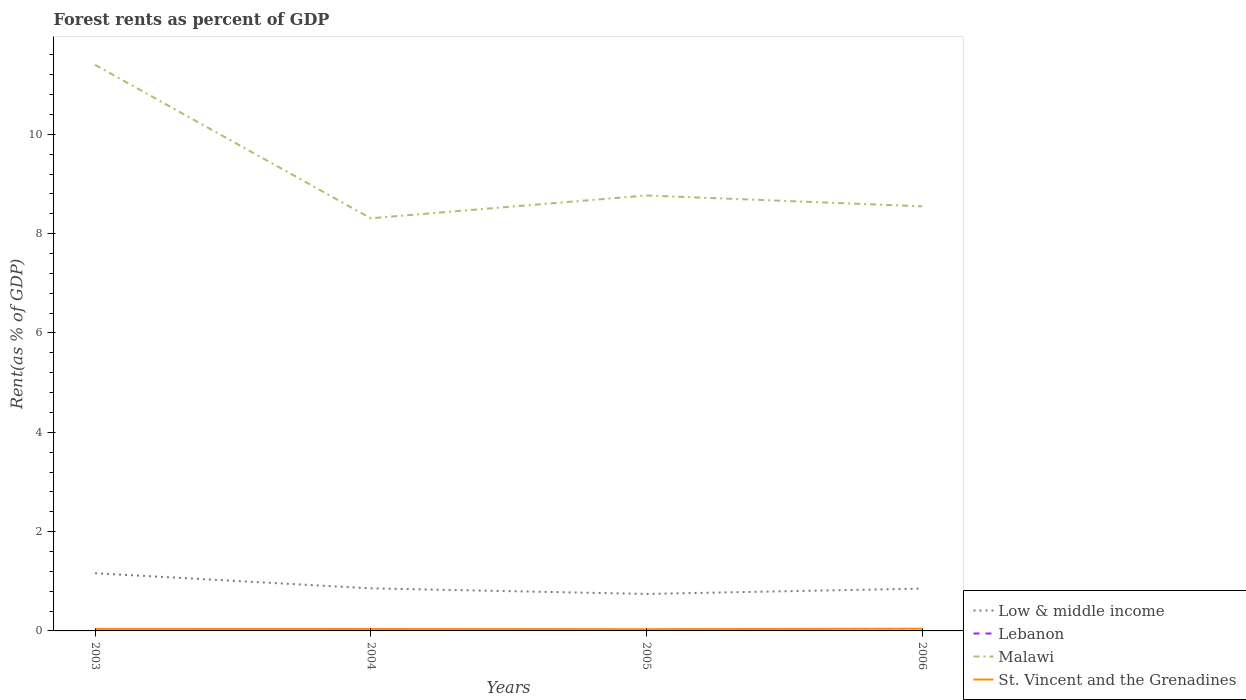How many different coloured lines are there?
Offer a very short reply. 4. Is the number of lines equal to the number of legend labels?
Give a very brief answer. Yes. Across all years, what is the maximum forest rent in St. Vincent and the Grenadines?
Provide a succinct answer. 0.03. In which year was the forest rent in Lebanon maximum?
Keep it short and to the point. 2006. What is the total forest rent in Low & middle income in the graph?
Keep it short and to the point. 0.01. What is the difference between the highest and the second highest forest rent in St. Vincent and the Grenadines?
Your response must be concise. 0.01. What is the difference between the highest and the lowest forest rent in St. Vincent and the Grenadines?
Your response must be concise. 2. How many lines are there?
Offer a very short reply. 4. How many years are there in the graph?
Offer a terse response. 4. What is the difference between two consecutive major ticks on the Y-axis?
Ensure brevity in your answer.  2. Where does the legend appear in the graph?
Make the answer very short. Bottom right. How many legend labels are there?
Offer a terse response. 4. How are the legend labels stacked?
Make the answer very short. Vertical. What is the title of the graph?
Your response must be concise. Forest rents as percent of GDP. Does "United Arab Emirates" appear as one of the legend labels in the graph?
Provide a short and direct response. No. What is the label or title of the Y-axis?
Offer a terse response. Rent(as % of GDP). What is the Rent(as % of GDP) of Low & middle income in 2003?
Offer a terse response. 1.16. What is the Rent(as % of GDP) in Lebanon in 2003?
Provide a succinct answer. 0. What is the Rent(as % of GDP) in Malawi in 2003?
Make the answer very short. 11.4. What is the Rent(as % of GDP) of St. Vincent and the Grenadines in 2003?
Ensure brevity in your answer.  0.04. What is the Rent(as % of GDP) in Low & middle income in 2004?
Give a very brief answer. 0.86. What is the Rent(as % of GDP) of Lebanon in 2004?
Keep it short and to the point. 0. What is the Rent(as % of GDP) of Malawi in 2004?
Your answer should be very brief. 8.31. What is the Rent(as % of GDP) of St. Vincent and the Grenadines in 2004?
Ensure brevity in your answer.  0.04. What is the Rent(as % of GDP) in Low & middle income in 2005?
Provide a succinct answer. 0.74. What is the Rent(as % of GDP) of Lebanon in 2005?
Ensure brevity in your answer.  0. What is the Rent(as % of GDP) of Malawi in 2005?
Ensure brevity in your answer.  8.77. What is the Rent(as % of GDP) of St. Vincent and the Grenadines in 2005?
Offer a terse response. 0.03. What is the Rent(as % of GDP) in Low & middle income in 2006?
Offer a terse response. 0.85. What is the Rent(as % of GDP) in Lebanon in 2006?
Your response must be concise. 0. What is the Rent(as % of GDP) in Malawi in 2006?
Ensure brevity in your answer.  8.55. What is the Rent(as % of GDP) of St. Vincent and the Grenadines in 2006?
Your answer should be compact. 0.05. Across all years, what is the maximum Rent(as % of GDP) in Low & middle income?
Ensure brevity in your answer.  1.16. Across all years, what is the maximum Rent(as % of GDP) of Lebanon?
Offer a terse response. 0. Across all years, what is the maximum Rent(as % of GDP) of Malawi?
Offer a terse response. 11.4. Across all years, what is the maximum Rent(as % of GDP) in St. Vincent and the Grenadines?
Keep it short and to the point. 0.05. Across all years, what is the minimum Rent(as % of GDP) in Low & middle income?
Offer a very short reply. 0.74. Across all years, what is the minimum Rent(as % of GDP) of Lebanon?
Offer a very short reply. 0. Across all years, what is the minimum Rent(as % of GDP) in Malawi?
Your answer should be compact. 8.31. Across all years, what is the minimum Rent(as % of GDP) of St. Vincent and the Grenadines?
Ensure brevity in your answer.  0.03. What is the total Rent(as % of GDP) in Low & middle income in the graph?
Your response must be concise. 3.62. What is the total Rent(as % of GDP) of Lebanon in the graph?
Provide a short and direct response. 0.02. What is the total Rent(as % of GDP) in Malawi in the graph?
Offer a very short reply. 37.03. What is the total Rent(as % of GDP) in St. Vincent and the Grenadines in the graph?
Give a very brief answer. 0.16. What is the difference between the Rent(as % of GDP) of Low & middle income in 2003 and that in 2004?
Give a very brief answer. 0.3. What is the difference between the Rent(as % of GDP) of Malawi in 2003 and that in 2004?
Ensure brevity in your answer.  3.09. What is the difference between the Rent(as % of GDP) in St. Vincent and the Grenadines in 2003 and that in 2004?
Your answer should be compact. 0. What is the difference between the Rent(as % of GDP) in Low & middle income in 2003 and that in 2005?
Ensure brevity in your answer.  0.42. What is the difference between the Rent(as % of GDP) of Malawi in 2003 and that in 2005?
Keep it short and to the point. 2.63. What is the difference between the Rent(as % of GDP) of St. Vincent and the Grenadines in 2003 and that in 2005?
Give a very brief answer. 0.01. What is the difference between the Rent(as % of GDP) in Low & middle income in 2003 and that in 2006?
Offer a terse response. 0.31. What is the difference between the Rent(as % of GDP) in Lebanon in 2003 and that in 2006?
Provide a succinct answer. 0. What is the difference between the Rent(as % of GDP) of Malawi in 2003 and that in 2006?
Keep it short and to the point. 2.85. What is the difference between the Rent(as % of GDP) in St. Vincent and the Grenadines in 2003 and that in 2006?
Your answer should be very brief. -0.01. What is the difference between the Rent(as % of GDP) in Low & middle income in 2004 and that in 2005?
Provide a succinct answer. 0.11. What is the difference between the Rent(as % of GDP) of Lebanon in 2004 and that in 2005?
Your response must be concise. 0. What is the difference between the Rent(as % of GDP) in Malawi in 2004 and that in 2005?
Provide a succinct answer. -0.46. What is the difference between the Rent(as % of GDP) of St. Vincent and the Grenadines in 2004 and that in 2005?
Ensure brevity in your answer.  0. What is the difference between the Rent(as % of GDP) of Low & middle income in 2004 and that in 2006?
Give a very brief answer. 0.01. What is the difference between the Rent(as % of GDP) in Lebanon in 2004 and that in 2006?
Offer a very short reply. 0. What is the difference between the Rent(as % of GDP) of Malawi in 2004 and that in 2006?
Make the answer very short. -0.24. What is the difference between the Rent(as % of GDP) in St. Vincent and the Grenadines in 2004 and that in 2006?
Offer a terse response. -0.01. What is the difference between the Rent(as % of GDP) of Low & middle income in 2005 and that in 2006?
Give a very brief answer. -0.11. What is the difference between the Rent(as % of GDP) of Lebanon in 2005 and that in 2006?
Give a very brief answer. 0. What is the difference between the Rent(as % of GDP) of Malawi in 2005 and that in 2006?
Offer a very short reply. 0.22. What is the difference between the Rent(as % of GDP) in St. Vincent and the Grenadines in 2005 and that in 2006?
Make the answer very short. -0.01. What is the difference between the Rent(as % of GDP) of Low & middle income in 2003 and the Rent(as % of GDP) of Lebanon in 2004?
Ensure brevity in your answer.  1.16. What is the difference between the Rent(as % of GDP) in Low & middle income in 2003 and the Rent(as % of GDP) in Malawi in 2004?
Provide a short and direct response. -7.15. What is the difference between the Rent(as % of GDP) in Low & middle income in 2003 and the Rent(as % of GDP) in St. Vincent and the Grenadines in 2004?
Ensure brevity in your answer.  1.12. What is the difference between the Rent(as % of GDP) in Lebanon in 2003 and the Rent(as % of GDP) in Malawi in 2004?
Your response must be concise. -8.31. What is the difference between the Rent(as % of GDP) in Lebanon in 2003 and the Rent(as % of GDP) in St. Vincent and the Grenadines in 2004?
Keep it short and to the point. -0.03. What is the difference between the Rent(as % of GDP) of Malawi in 2003 and the Rent(as % of GDP) of St. Vincent and the Grenadines in 2004?
Offer a very short reply. 11.36. What is the difference between the Rent(as % of GDP) of Low & middle income in 2003 and the Rent(as % of GDP) of Lebanon in 2005?
Make the answer very short. 1.16. What is the difference between the Rent(as % of GDP) in Low & middle income in 2003 and the Rent(as % of GDP) in Malawi in 2005?
Keep it short and to the point. -7.61. What is the difference between the Rent(as % of GDP) in Low & middle income in 2003 and the Rent(as % of GDP) in St. Vincent and the Grenadines in 2005?
Give a very brief answer. 1.13. What is the difference between the Rent(as % of GDP) in Lebanon in 2003 and the Rent(as % of GDP) in Malawi in 2005?
Keep it short and to the point. -8.77. What is the difference between the Rent(as % of GDP) of Lebanon in 2003 and the Rent(as % of GDP) of St. Vincent and the Grenadines in 2005?
Ensure brevity in your answer.  -0.03. What is the difference between the Rent(as % of GDP) of Malawi in 2003 and the Rent(as % of GDP) of St. Vincent and the Grenadines in 2005?
Your response must be concise. 11.36. What is the difference between the Rent(as % of GDP) of Low & middle income in 2003 and the Rent(as % of GDP) of Lebanon in 2006?
Make the answer very short. 1.16. What is the difference between the Rent(as % of GDP) in Low & middle income in 2003 and the Rent(as % of GDP) in Malawi in 2006?
Provide a short and direct response. -7.39. What is the difference between the Rent(as % of GDP) in Low & middle income in 2003 and the Rent(as % of GDP) in St. Vincent and the Grenadines in 2006?
Give a very brief answer. 1.12. What is the difference between the Rent(as % of GDP) of Lebanon in 2003 and the Rent(as % of GDP) of Malawi in 2006?
Keep it short and to the point. -8.55. What is the difference between the Rent(as % of GDP) of Lebanon in 2003 and the Rent(as % of GDP) of St. Vincent and the Grenadines in 2006?
Ensure brevity in your answer.  -0.04. What is the difference between the Rent(as % of GDP) of Malawi in 2003 and the Rent(as % of GDP) of St. Vincent and the Grenadines in 2006?
Give a very brief answer. 11.35. What is the difference between the Rent(as % of GDP) in Low & middle income in 2004 and the Rent(as % of GDP) in Lebanon in 2005?
Your answer should be compact. 0.85. What is the difference between the Rent(as % of GDP) in Low & middle income in 2004 and the Rent(as % of GDP) in Malawi in 2005?
Your answer should be very brief. -7.91. What is the difference between the Rent(as % of GDP) in Low & middle income in 2004 and the Rent(as % of GDP) in St. Vincent and the Grenadines in 2005?
Your answer should be compact. 0.82. What is the difference between the Rent(as % of GDP) in Lebanon in 2004 and the Rent(as % of GDP) in Malawi in 2005?
Your answer should be very brief. -8.77. What is the difference between the Rent(as % of GDP) of Lebanon in 2004 and the Rent(as % of GDP) of St. Vincent and the Grenadines in 2005?
Make the answer very short. -0.03. What is the difference between the Rent(as % of GDP) in Malawi in 2004 and the Rent(as % of GDP) in St. Vincent and the Grenadines in 2005?
Make the answer very short. 8.28. What is the difference between the Rent(as % of GDP) of Low & middle income in 2004 and the Rent(as % of GDP) of Lebanon in 2006?
Your answer should be very brief. 0.85. What is the difference between the Rent(as % of GDP) in Low & middle income in 2004 and the Rent(as % of GDP) in Malawi in 2006?
Your answer should be compact. -7.69. What is the difference between the Rent(as % of GDP) in Low & middle income in 2004 and the Rent(as % of GDP) in St. Vincent and the Grenadines in 2006?
Your answer should be compact. 0.81. What is the difference between the Rent(as % of GDP) of Lebanon in 2004 and the Rent(as % of GDP) of Malawi in 2006?
Offer a very short reply. -8.55. What is the difference between the Rent(as % of GDP) in Lebanon in 2004 and the Rent(as % of GDP) in St. Vincent and the Grenadines in 2006?
Provide a short and direct response. -0.04. What is the difference between the Rent(as % of GDP) of Malawi in 2004 and the Rent(as % of GDP) of St. Vincent and the Grenadines in 2006?
Your response must be concise. 8.26. What is the difference between the Rent(as % of GDP) in Low & middle income in 2005 and the Rent(as % of GDP) in Lebanon in 2006?
Provide a succinct answer. 0.74. What is the difference between the Rent(as % of GDP) in Low & middle income in 2005 and the Rent(as % of GDP) in Malawi in 2006?
Your response must be concise. -7.81. What is the difference between the Rent(as % of GDP) in Low & middle income in 2005 and the Rent(as % of GDP) in St. Vincent and the Grenadines in 2006?
Provide a succinct answer. 0.7. What is the difference between the Rent(as % of GDP) in Lebanon in 2005 and the Rent(as % of GDP) in Malawi in 2006?
Provide a short and direct response. -8.55. What is the difference between the Rent(as % of GDP) in Lebanon in 2005 and the Rent(as % of GDP) in St. Vincent and the Grenadines in 2006?
Your answer should be compact. -0.04. What is the difference between the Rent(as % of GDP) of Malawi in 2005 and the Rent(as % of GDP) of St. Vincent and the Grenadines in 2006?
Make the answer very short. 8.72. What is the average Rent(as % of GDP) of Low & middle income per year?
Your answer should be compact. 0.9. What is the average Rent(as % of GDP) of Lebanon per year?
Make the answer very short. 0. What is the average Rent(as % of GDP) of Malawi per year?
Offer a very short reply. 9.26. What is the average Rent(as % of GDP) of St. Vincent and the Grenadines per year?
Give a very brief answer. 0.04. In the year 2003, what is the difference between the Rent(as % of GDP) of Low & middle income and Rent(as % of GDP) of Lebanon?
Make the answer very short. 1.16. In the year 2003, what is the difference between the Rent(as % of GDP) in Low & middle income and Rent(as % of GDP) in Malawi?
Provide a short and direct response. -10.24. In the year 2003, what is the difference between the Rent(as % of GDP) in Low & middle income and Rent(as % of GDP) in St. Vincent and the Grenadines?
Give a very brief answer. 1.12. In the year 2003, what is the difference between the Rent(as % of GDP) of Lebanon and Rent(as % of GDP) of Malawi?
Give a very brief answer. -11.39. In the year 2003, what is the difference between the Rent(as % of GDP) of Lebanon and Rent(as % of GDP) of St. Vincent and the Grenadines?
Ensure brevity in your answer.  -0.04. In the year 2003, what is the difference between the Rent(as % of GDP) of Malawi and Rent(as % of GDP) of St. Vincent and the Grenadines?
Give a very brief answer. 11.36. In the year 2004, what is the difference between the Rent(as % of GDP) in Low & middle income and Rent(as % of GDP) in Lebanon?
Your answer should be compact. 0.85. In the year 2004, what is the difference between the Rent(as % of GDP) of Low & middle income and Rent(as % of GDP) of Malawi?
Ensure brevity in your answer.  -7.45. In the year 2004, what is the difference between the Rent(as % of GDP) in Low & middle income and Rent(as % of GDP) in St. Vincent and the Grenadines?
Provide a short and direct response. 0.82. In the year 2004, what is the difference between the Rent(as % of GDP) in Lebanon and Rent(as % of GDP) in Malawi?
Provide a succinct answer. -8.31. In the year 2004, what is the difference between the Rent(as % of GDP) in Lebanon and Rent(as % of GDP) in St. Vincent and the Grenadines?
Keep it short and to the point. -0.03. In the year 2004, what is the difference between the Rent(as % of GDP) in Malawi and Rent(as % of GDP) in St. Vincent and the Grenadines?
Provide a succinct answer. 8.27. In the year 2005, what is the difference between the Rent(as % of GDP) of Low & middle income and Rent(as % of GDP) of Lebanon?
Ensure brevity in your answer.  0.74. In the year 2005, what is the difference between the Rent(as % of GDP) in Low & middle income and Rent(as % of GDP) in Malawi?
Your response must be concise. -8.02. In the year 2005, what is the difference between the Rent(as % of GDP) in Low & middle income and Rent(as % of GDP) in St. Vincent and the Grenadines?
Keep it short and to the point. 0.71. In the year 2005, what is the difference between the Rent(as % of GDP) of Lebanon and Rent(as % of GDP) of Malawi?
Your answer should be compact. -8.77. In the year 2005, what is the difference between the Rent(as % of GDP) in Lebanon and Rent(as % of GDP) in St. Vincent and the Grenadines?
Your response must be concise. -0.03. In the year 2005, what is the difference between the Rent(as % of GDP) of Malawi and Rent(as % of GDP) of St. Vincent and the Grenadines?
Provide a succinct answer. 8.73. In the year 2006, what is the difference between the Rent(as % of GDP) of Low & middle income and Rent(as % of GDP) of Lebanon?
Provide a succinct answer. 0.85. In the year 2006, what is the difference between the Rent(as % of GDP) of Low & middle income and Rent(as % of GDP) of Malawi?
Keep it short and to the point. -7.7. In the year 2006, what is the difference between the Rent(as % of GDP) in Low & middle income and Rent(as % of GDP) in St. Vincent and the Grenadines?
Offer a terse response. 0.81. In the year 2006, what is the difference between the Rent(as % of GDP) of Lebanon and Rent(as % of GDP) of Malawi?
Offer a very short reply. -8.55. In the year 2006, what is the difference between the Rent(as % of GDP) in Lebanon and Rent(as % of GDP) in St. Vincent and the Grenadines?
Give a very brief answer. -0.04. In the year 2006, what is the difference between the Rent(as % of GDP) of Malawi and Rent(as % of GDP) of St. Vincent and the Grenadines?
Your answer should be compact. 8.51. What is the ratio of the Rent(as % of GDP) in Low & middle income in 2003 to that in 2004?
Your answer should be compact. 1.36. What is the ratio of the Rent(as % of GDP) in Lebanon in 2003 to that in 2004?
Offer a terse response. 1.07. What is the ratio of the Rent(as % of GDP) in Malawi in 2003 to that in 2004?
Your answer should be compact. 1.37. What is the ratio of the Rent(as % of GDP) in St. Vincent and the Grenadines in 2003 to that in 2004?
Provide a succinct answer. 1.05. What is the ratio of the Rent(as % of GDP) in Low & middle income in 2003 to that in 2005?
Offer a terse response. 1.56. What is the ratio of the Rent(as % of GDP) in Lebanon in 2003 to that in 2005?
Your answer should be compact. 1.11. What is the ratio of the Rent(as % of GDP) of Malawi in 2003 to that in 2005?
Offer a very short reply. 1.3. What is the ratio of the Rent(as % of GDP) of St. Vincent and the Grenadines in 2003 to that in 2005?
Your response must be concise. 1.17. What is the ratio of the Rent(as % of GDP) in Low & middle income in 2003 to that in 2006?
Keep it short and to the point. 1.36. What is the ratio of the Rent(as % of GDP) in Lebanon in 2003 to that in 2006?
Provide a succinct answer. 1.12. What is the ratio of the Rent(as % of GDP) in Malawi in 2003 to that in 2006?
Ensure brevity in your answer.  1.33. What is the ratio of the Rent(as % of GDP) of St. Vincent and the Grenadines in 2003 to that in 2006?
Your answer should be very brief. 0.88. What is the ratio of the Rent(as % of GDP) in Low & middle income in 2004 to that in 2005?
Provide a succinct answer. 1.15. What is the ratio of the Rent(as % of GDP) of Lebanon in 2004 to that in 2005?
Ensure brevity in your answer.  1.04. What is the ratio of the Rent(as % of GDP) of Malawi in 2004 to that in 2005?
Offer a very short reply. 0.95. What is the ratio of the Rent(as % of GDP) in St. Vincent and the Grenadines in 2004 to that in 2005?
Keep it short and to the point. 1.12. What is the ratio of the Rent(as % of GDP) in Lebanon in 2004 to that in 2006?
Give a very brief answer. 1.05. What is the ratio of the Rent(as % of GDP) of Malawi in 2004 to that in 2006?
Provide a succinct answer. 0.97. What is the ratio of the Rent(as % of GDP) of St. Vincent and the Grenadines in 2004 to that in 2006?
Your answer should be very brief. 0.84. What is the ratio of the Rent(as % of GDP) in Low & middle income in 2005 to that in 2006?
Offer a terse response. 0.87. What is the ratio of the Rent(as % of GDP) in Lebanon in 2005 to that in 2006?
Your response must be concise. 1.01. What is the ratio of the Rent(as % of GDP) of Malawi in 2005 to that in 2006?
Your response must be concise. 1.03. What is the ratio of the Rent(as % of GDP) in St. Vincent and the Grenadines in 2005 to that in 2006?
Ensure brevity in your answer.  0.75. What is the difference between the highest and the second highest Rent(as % of GDP) in Low & middle income?
Your answer should be compact. 0.3. What is the difference between the highest and the second highest Rent(as % of GDP) of Malawi?
Offer a terse response. 2.63. What is the difference between the highest and the second highest Rent(as % of GDP) of St. Vincent and the Grenadines?
Provide a succinct answer. 0.01. What is the difference between the highest and the lowest Rent(as % of GDP) of Low & middle income?
Provide a succinct answer. 0.42. What is the difference between the highest and the lowest Rent(as % of GDP) in Lebanon?
Make the answer very short. 0. What is the difference between the highest and the lowest Rent(as % of GDP) of Malawi?
Keep it short and to the point. 3.09. What is the difference between the highest and the lowest Rent(as % of GDP) in St. Vincent and the Grenadines?
Your answer should be very brief. 0.01. 